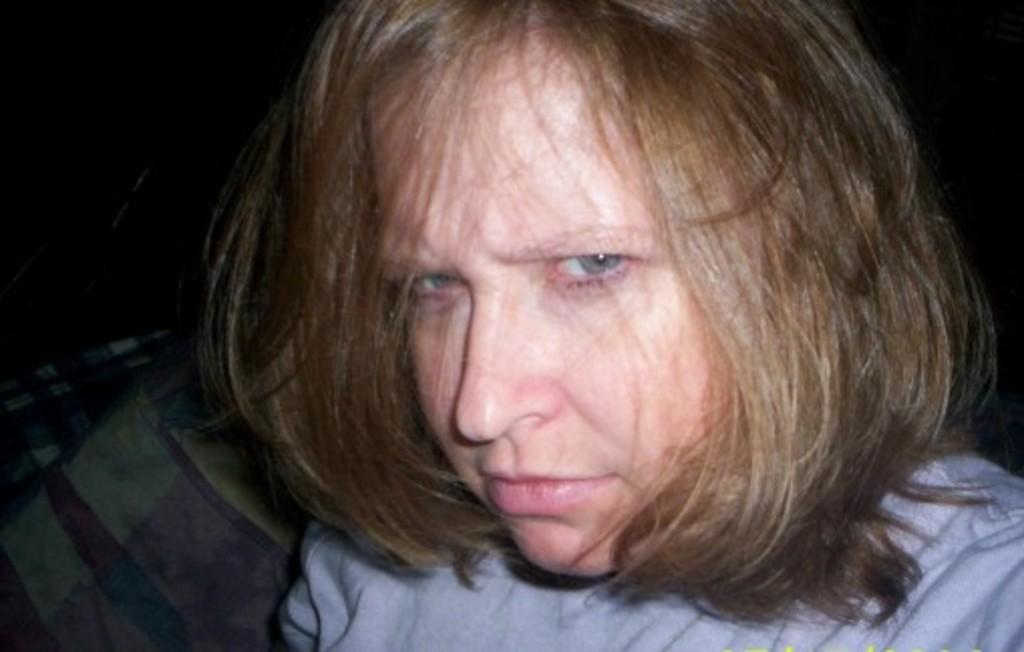Who is the main subject in the image? There is a woman in the image. What is the woman wearing? The woman is wearing a blue dress. What color is the background of the image? The background of the image appears to be black. What type of corn can be seen in the woman's hair in the image? There is no corn present in the image, nor is there any corn in the woman's hair. 